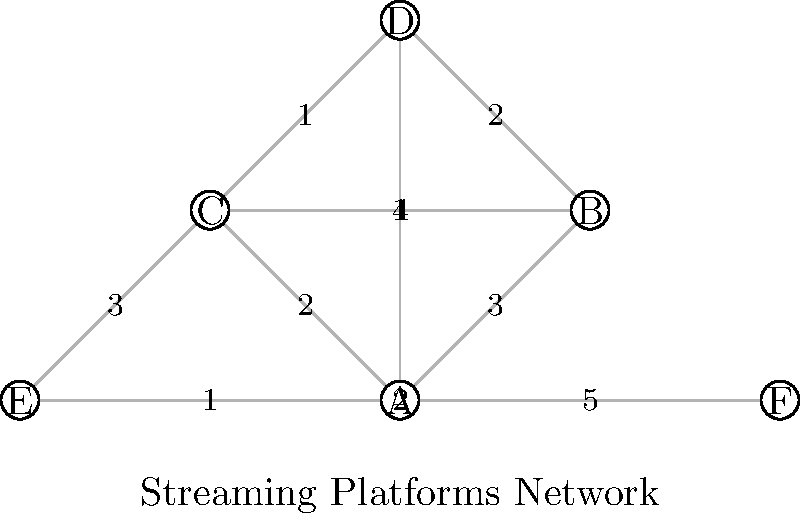In the network topology of music streaming platforms shown above, each node represents a different platform or distribution channel, and the edges represent connections between them with weights indicating the strength of the connection. What is the minimum number of platforms an underground hip hop artist needs to use to reach all other platforms in the network, assuming they start from platform A? To solve this problem, we need to find the minimum spanning tree (MST) of the graph starting from node A. The MST will give us the minimum number of connections needed to reach all nodes. We'll use Prim's algorithm to find the MST:

1. Start with node A.
2. Choose the edge with the lowest weight connected to A: A-E with weight 1.
3. From A and E, the next lowest weight edge is E-F with weight 2.
4. From A, E, and F, the next lowest weight edge is A-C with weight 2.
5. From A, C, E, and F, the next lowest weight edge is C-D with weight 1.
6. Finally, connect C-B with weight 1 to include the last node.

The resulting MST includes 5 edges: A-E, E-F, A-C, C-D, and C-B.

Since each edge represents a connection between two platforms, the number of platforms needed is one more than the number of edges in the MST.

Therefore, the minimum number of platforms needed is 5 + 1 = 6.
Answer: 6 platforms 